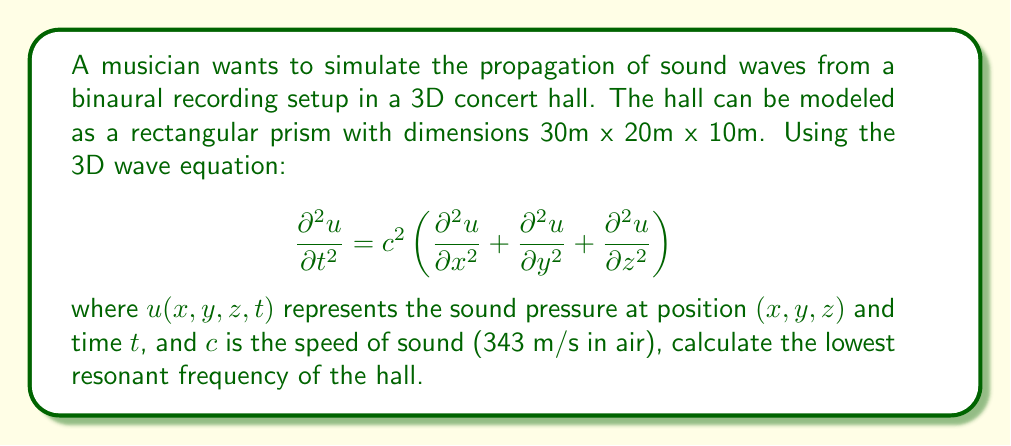Show me your answer to this math problem. To solve this problem, we need to follow these steps:

1) The resonant frequencies of a rectangular room are given by the equation:

   $$f_{nx,ny,nz} = \frac{c}{2} \sqrt{\left(\frac{n_x}{L_x}\right)^2 + \left(\frac{n_y}{L_y}\right)^2 + \left(\frac{n_z}{L_z}\right)^2}$$

   where $n_x$, $n_y$, and $n_z$ are non-negative integers, and $L_x$, $L_y$, and $L_z$ are the dimensions of the room.

2) The lowest resonant frequency occurs when $n_x = 1$, $n_y = 0$, and $n_z = 0$. This corresponds to the longest dimension of the room.

3) In this case, $L_x = 30$ m (the longest dimension).

4) Substituting these values into the equation:

   $$f_{1,0,0} = \frac{343}{2} \sqrt{\left(\frac{1}{30}\right)^2 + 0^2 + 0^2}$$

5) Simplifying:

   $$f_{1,0,0} = \frac{343}{2} \cdot \frac{1}{30} = \frac{343}{60} \approx 5.72 \text{ Hz}$$

Therefore, the lowest resonant frequency of the hall is approximately 5.72 Hz.
Answer: 5.72 Hz 